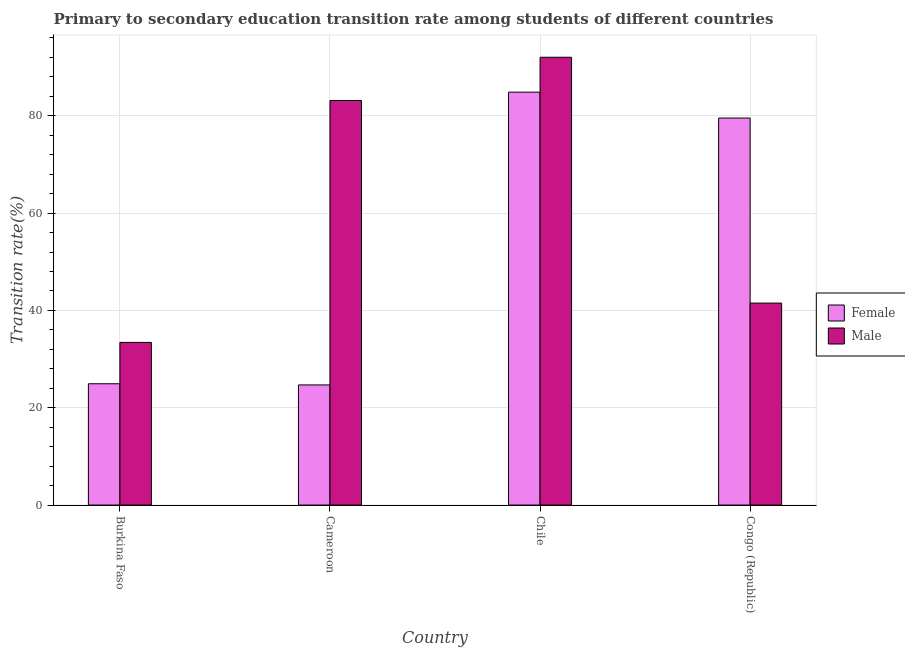How many different coloured bars are there?
Your response must be concise. 2. Are the number of bars per tick equal to the number of legend labels?
Ensure brevity in your answer.  Yes. How many bars are there on the 2nd tick from the left?
Provide a succinct answer. 2. What is the label of the 2nd group of bars from the left?
Ensure brevity in your answer.  Cameroon. What is the transition rate among female students in Congo (Republic)?
Your answer should be very brief. 79.54. Across all countries, what is the maximum transition rate among female students?
Offer a terse response. 84.86. Across all countries, what is the minimum transition rate among female students?
Offer a very short reply. 24.69. In which country was the transition rate among male students minimum?
Give a very brief answer. Burkina Faso. What is the total transition rate among female students in the graph?
Keep it short and to the point. 214.01. What is the difference between the transition rate among female students in Burkina Faso and that in Cameroon?
Give a very brief answer. 0.24. What is the difference between the transition rate among female students in Congo (Republic) and the transition rate among male students in Cameroon?
Provide a short and direct response. -3.6. What is the average transition rate among female students per country?
Your answer should be very brief. 53.5. What is the difference between the transition rate among female students and transition rate among male students in Burkina Faso?
Your answer should be very brief. -8.49. In how many countries, is the transition rate among female students greater than 48 %?
Offer a very short reply. 2. What is the ratio of the transition rate among female students in Cameroon to that in Chile?
Keep it short and to the point. 0.29. Is the transition rate among female students in Burkina Faso less than that in Cameroon?
Your answer should be compact. No. Is the difference between the transition rate among female students in Burkina Faso and Congo (Republic) greater than the difference between the transition rate among male students in Burkina Faso and Congo (Republic)?
Your response must be concise. No. What is the difference between the highest and the second highest transition rate among male students?
Give a very brief answer. 8.89. What is the difference between the highest and the lowest transition rate among female students?
Provide a succinct answer. 60.17. How many countries are there in the graph?
Your answer should be very brief. 4. What is the difference between two consecutive major ticks on the Y-axis?
Offer a very short reply. 20. Does the graph contain any zero values?
Provide a succinct answer. No. Does the graph contain grids?
Offer a terse response. Yes. Where does the legend appear in the graph?
Provide a short and direct response. Center right. How are the legend labels stacked?
Offer a very short reply. Vertical. What is the title of the graph?
Provide a succinct answer. Primary to secondary education transition rate among students of different countries. What is the label or title of the X-axis?
Provide a succinct answer. Country. What is the label or title of the Y-axis?
Your answer should be very brief. Transition rate(%). What is the Transition rate(%) of Female in Burkina Faso?
Your answer should be compact. 24.93. What is the Transition rate(%) of Male in Burkina Faso?
Your answer should be very brief. 33.43. What is the Transition rate(%) of Female in Cameroon?
Give a very brief answer. 24.69. What is the Transition rate(%) of Male in Cameroon?
Ensure brevity in your answer.  83.13. What is the Transition rate(%) in Female in Chile?
Make the answer very short. 84.86. What is the Transition rate(%) in Male in Chile?
Offer a very short reply. 92.02. What is the Transition rate(%) of Female in Congo (Republic)?
Ensure brevity in your answer.  79.54. What is the Transition rate(%) in Male in Congo (Republic)?
Keep it short and to the point. 41.51. Across all countries, what is the maximum Transition rate(%) in Female?
Give a very brief answer. 84.86. Across all countries, what is the maximum Transition rate(%) in Male?
Offer a terse response. 92.02. Across all countries, what is the minimum Transition rate(%) of Female?
Your answer should be compact. 24.69. Across all countries, what is the minimum Transition rate(%) in Male?
Offer a very short reply. 33.43. What is the total Transition rate(%) of Female in the graph?
Give a very brief answer. 214.01. What is the total Transition rate(%) in Male in the graph?
Make the answer very short. 250.09. What is the difference between the Transition rate(%) of Female in Burkina Faso and that in Cameroon?
Give a very brief answer. 0.24. What is the difference between the Transition rate(%) in Male in Burkina Faso and that in Cameroon?
Ensure brevity in your answer.  -49.71. What is the difference between the Transition rate(%) of Female in Burkina Faso and that in Chile?
Your response must be concise. -59.92. What is the difference between the Transition rate(%) in Male in Burkina Faso and that in Chile?
Provide a succinct answer. -58.6. What is the difference between the Transition rate(%) of Female in Burkina Faso and that in Congo (Republic)?
Offer a very short reply. -54.6. What is the difference between the Transition rate(%) in Male in Burkina Faso and that in Congo (Republic)?
Your answer should be very brief. -8.08. What is the difference between the Transition rate(%) in Female in Cameroon and that in Chile?
Your answer should be very brief. -60.17. What is the difference between the Transition rate(%) in Male in Cameroon and that in Chile?
Offer a very short reply. -8.89. What is the difference between the Transition rate(%) of Female in Cameroon and that in Congo (Republic)?
Offer a very short reply. -54.85. What is the difference between the Transition rate(%) of Male in Cameroon and that in Congo (Republic)?
Your response must be concise. 41.63. What is the difference between the Transition rate(%) in Female in Chile and that in Congo (Republic)?
Offer a terse response. 5.32. What is the difference between the Transition rate(%) of Male in Chile and that in Congo (Republic)?
Your answer should be compact. 50.52. What is the difference between the Transition rate(%) of Female in Burkina Faso and the Transition rate(%) of Male in Cameroon?
Your answer should be very brief. -58.2. What is the difference between the Transition rate(%) of Female in Burkina Faso and the Transition rate(%) of Male in Chile?
Offer a terse response. -67.09. What is the difference between the Transition rate(%) in Female in Burkina Faso and the Transition rate(%) in Male in Congo (Republic)?
Your response must be concise. -16.58. What is the difference between the Transition rate(%) of Female in Cameroon and the Transition rate(%) of Male in Chile?
Offer a terse response. -67.33. What is the difference between the Transition rate(%) in Female in Cameroon and the Transition rate(%) in Male in Congo (Republic)?
Your answer should be compact. -16.82. What is the difference between the Transition rate(%) of Female in Chile and the Transition rate(%) of Male in Congo (Republic)?
Make the answer very short. 43.35. What is the average Transition rate(%) of Female per country?
Your response must be concise. 53.5. What is the average Transition rate(%) in Male per country?
Your response must be concise. 62.52. What is the difference between the Transition rate(%) in Female and Transition rate(%) in Male in Burkina Faso?
Provide a succinct answer. -8.49. What is the difference between the Transition rate(%) in Female and Transition rate(%) in Male in Cameroon?
Give a very brief answer. -58.44. What is the difference between the Transition rate(%) in Female and Transition rate(%) in Male in Chile?
Provide a short and direct response. -7.17. What is the difference between the Transition rate(%) in Female and Transition rate(%) in Male in Congo (Republic)?
Your response must be concise. 38.03. What is the ratio of the Transition rate(%) of Female in Burkina Faso to that in Cameroon?
Give a very brief answer. 1.01. What is the ratio of the Transition rate(%) in Male in Burkina Faso to that in Cameroon?
Your answer should be very brief. 0.4. What is the ratio of the Transition rate(%) of Female in Burkina Faso to that in Chile?
Provide a succinct answer. 0.29. What is the ratio of the Transition rate(%) of Male in Burkina Faso to that in Chile?
Offer a very short reply. 0.36. What is the ratio of the Transition rate(%) in Female in Burkina Faso to that in Congo (Republic)?
Offer a terse response. 0.31. What is the ratio of the Transition rate(%) in Male in Burkina Faso to that in Congo (Republic)?
Your answer should be compact. 0.81. What is the ratio of the Transition rate(%) in Female in Cameroon to that in Chile?
Provide a short and direct response. 0.29. What is the ratio of the Transition rate(%) of Male in Cameroon to that in Chile?
Keep it short and to the point. 0.9. What is the ratio of the Transition rate(%) in Female in Cameroon to that in Congo (Republic)?
Offer a very short reply. 0.31. What is the ratio of the Transition rate(%) of Male in Cameroon to that in Congo (Republic)?
Offer a terse response. 2. What is the ratio of the Transition rate(%) of Female in Chile to that in Congo (Republic)?
Make the answer very short. 1.07. What is the ratio of the Transition rate(%) in Male in Chile to that in Congo (Republic)?
Your answer should be very brief. 2.22. What is the difference between the highest and the second highest Transition rate(%) of Female?
Your response must be concise. 5.32. What is the difference between the highest and the second highest Transition rate(%) in Male?
Your response must be concise. 8.89. What is the difference between the highest and the lowest Transition rate(%) in Female?
Offer a very short reply. 60.17. What is the difference between the highest and the lowest Transition rate(%) in Male?
Offer a terse response. 58.6. 